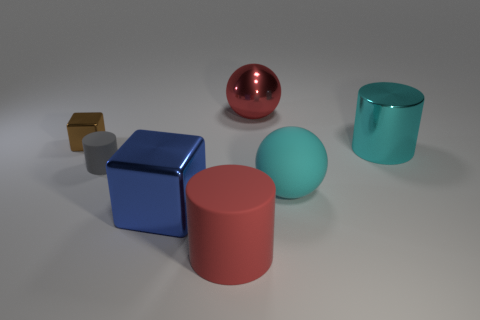Subtract all matte cylinders. How many cylinders are left? 1 Add 2 small purple cubes. How many objects exist? 9 Subtract all cylinders. How many objects are left? 4 Subtract all tiny gray matte cylinders. Subtract all tiny cubes. How many objects are left? 5 Add 3 big objects. How many big objects are left? 8 Add 4 spheres. How many spheres exist? 6 Subtract 0 yellow cubes. How many objects are left? 7 